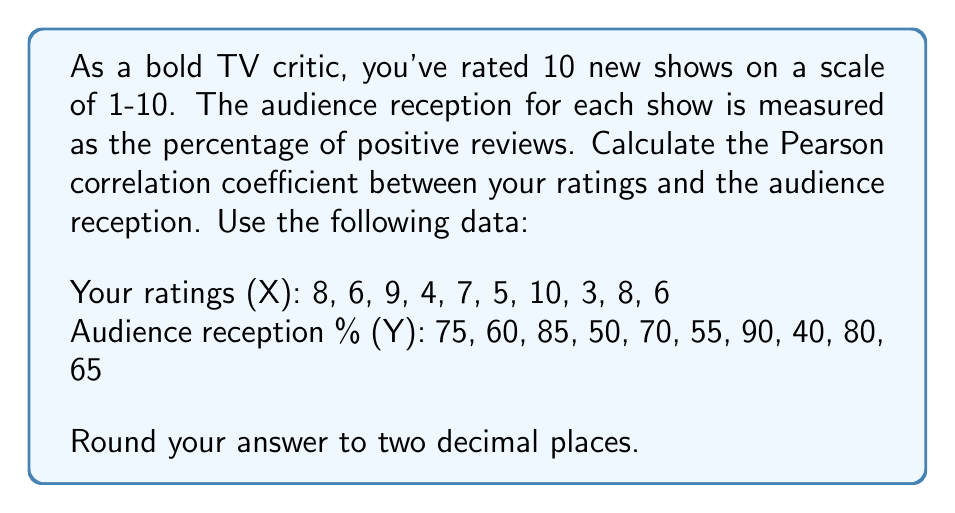Teach me how to tackle this problem. To calculate the Pearson correlation coefficient (r), we'll use the formula:

$$ r = \frac{n\sum xy - \sum x \sum y}{\sqrt{[n\sum x^2 - (\sum x)^2][n\sum y^2 - (\sum y)^2]}} $$

Step 1: Calculate the necessary sums:
$\sum x = 66$
$\sum y = 670$
$\sum xy = 4,635$
$\sum x^2 = 478$
$\sum y^2 = 46,550$
$n = 10$

Step 2: Substitute these values into the formula:

$$ r = \frac{10(4,635) - (66)(670)}{\sqrt{[10(478) - 66^2][10(46,550) - 670^2]}} $$

Step 3: Simplify:

$$ r = \frac{46,350 - 44,220}{\sqrt{(4,780 - 4,356)(465,500 - 448,900)}} $$

$$ r = \frac{2,130}{\sqrt{424 \times 16,600}} $$

$$ r = \frac{2,130}{\sqrt{7,038,400}} $$

$$ r = \frac{2,130}{2,652.96} $$

Step 4: Calculate and round to two decimal places:

$$ r \approx 0.80 $$
Answer: 0.80 